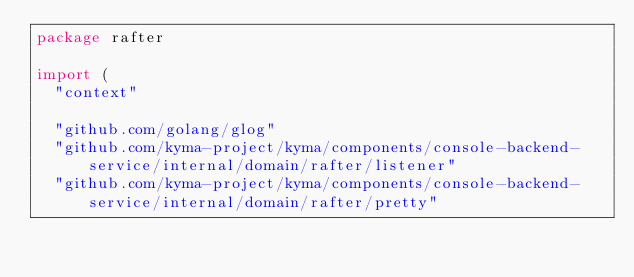Convert code to text. <code><loc_0><loc_0><loc_500><loc_500><_Go_>package rafter

import (
	"context"

	"github.com/golang/glog"
	"github.com/kyma-project/kyma/components/console-backend-service/internal/domain/rafter/listener"
	"github.com/kyma-project/kyma/components/console-backend-service/internal/domain/rafter/pretty"</code> 